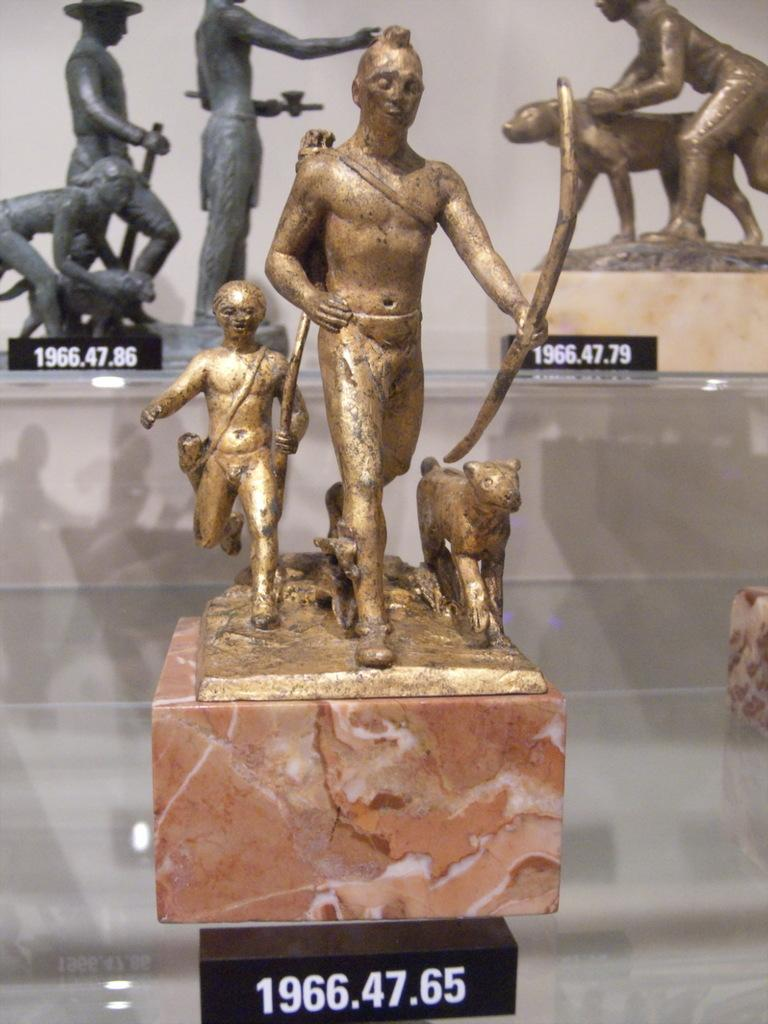What type of objects are in the image? There is a group of gold-colored sculptures or statues in the image. How are the sculptures or statues arranged? The sculptures or statues are placed in a glass rack. Are there any additional features associated with the sculptures or statues? Yes, there are number boards associated with the sculptures or statues. What type of produce is being ploughed in the image? There is no produce or ploughing activity present in the image; it features a group of gold-colored sculptures or statues in a glass rack with number boards. 